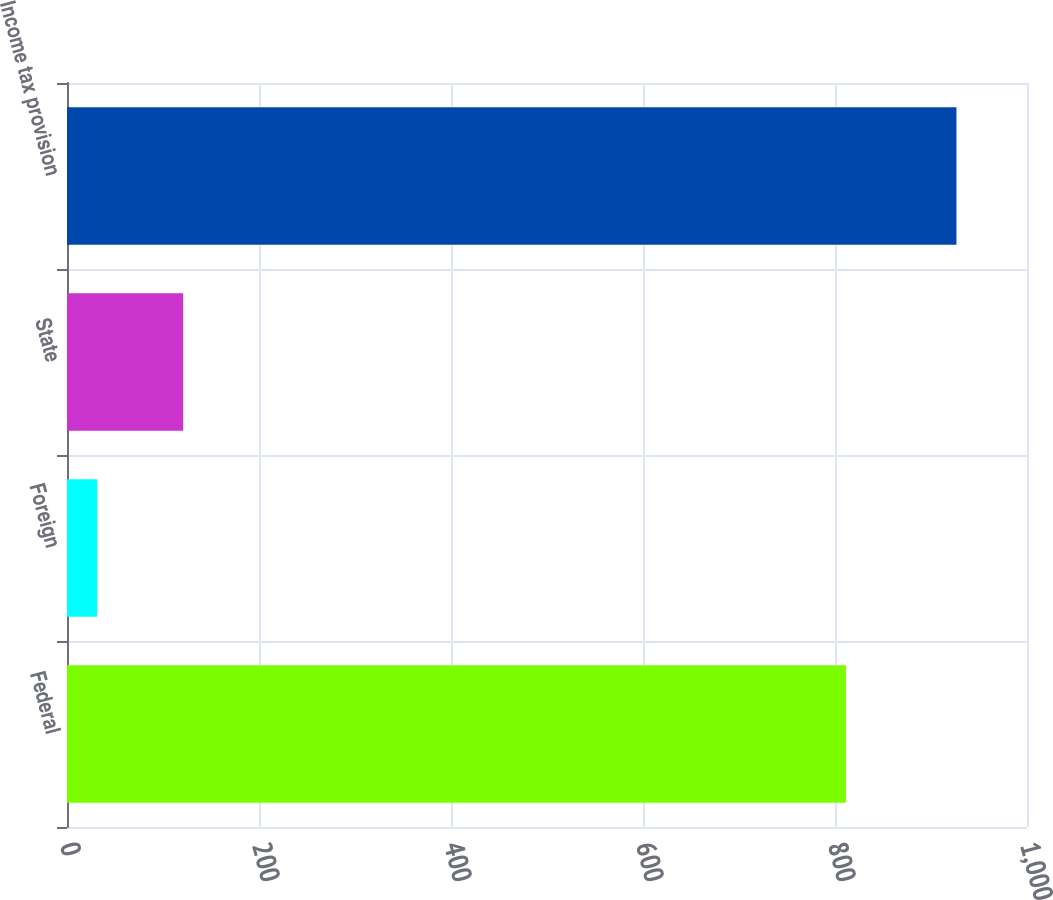Convert chart to OTSL. <chart><loc_0><loc_0><loc_500><loc_500><bar_chart><fcel>Federal<fcel>Foreign<fcel>State<fcel>Income tax provision<nl><fcel>811.4<fcel>31.5<fcel>121<fcel>926.5<nl></chart> 